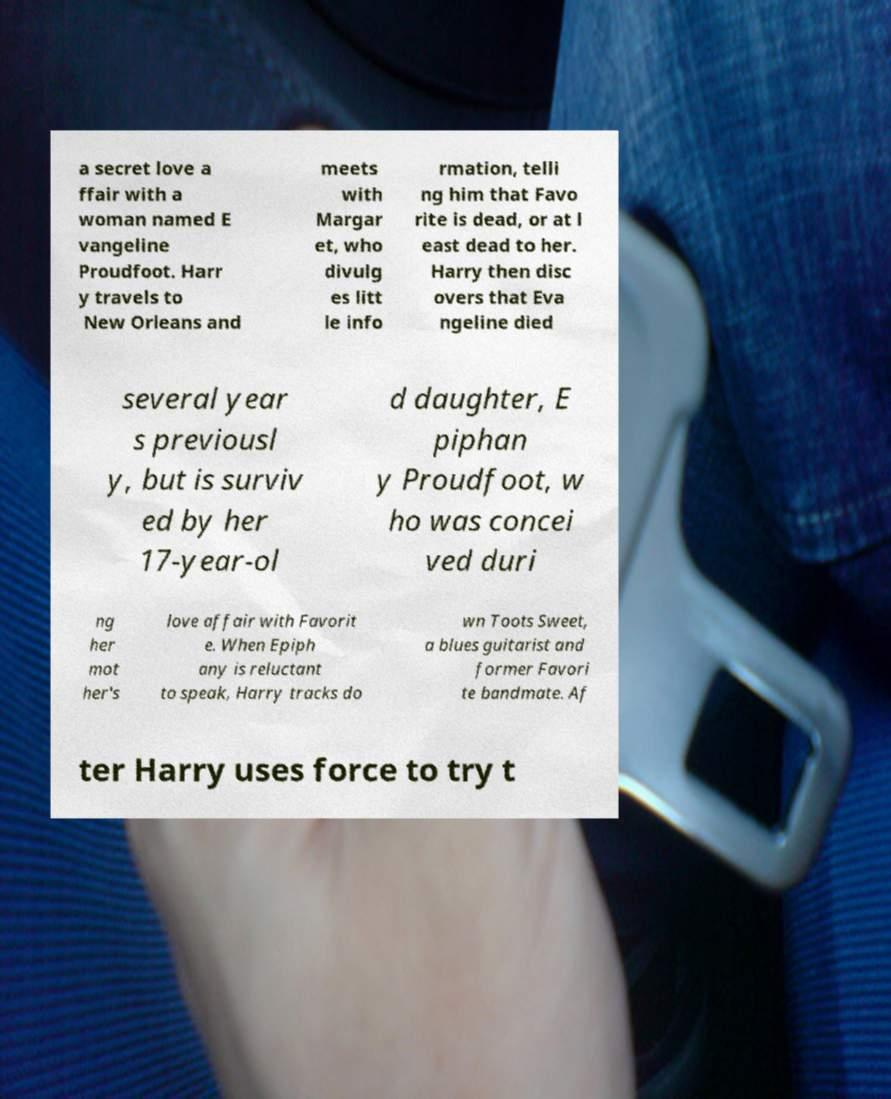Can you accurately transcribe the text from the provided image for me? a secret love a ffair with a woman named E vangeline Proudfoot. Harr y travels to New Orleans and meets with Margar et, who divulg es litt le info rmation, telli ng him that Favo rite is dead, or at l east dead to her. Harry then disc overs that Eva ngeline died several year s previousl y, but is surviv ed by her 17-year-ol d daughter, E piphan y Proudfoot, w ho was concei ved duri ng her mot her's love affair with Favorit e. When Epiph any is reluctant to speak, Harry tracks do wn Toots Sweet, a blues guitarist and former Favori te bandmate. Af ter Harry uses force to try t 